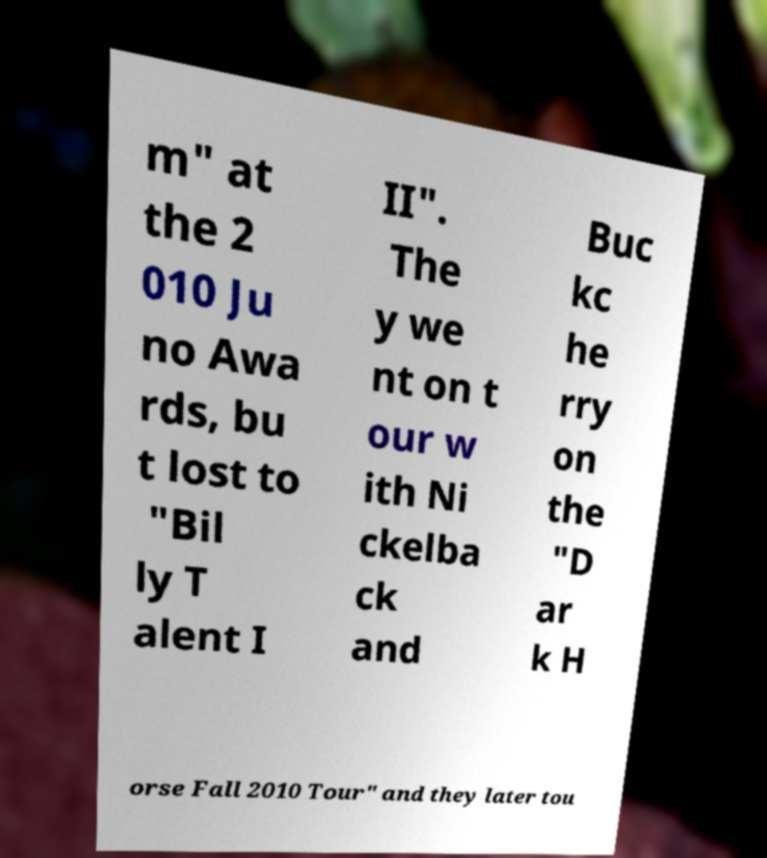Please identify and transcribe the text found in this image. m" at the 2 010 Ju no Awa rds, bu t lost to "Bil ly T alent I II". The y we nt on t our w ith Ni ckelba ck and Buc kc he rry on the "D ar k H orse Fall 2010 Tour" and they later tou 